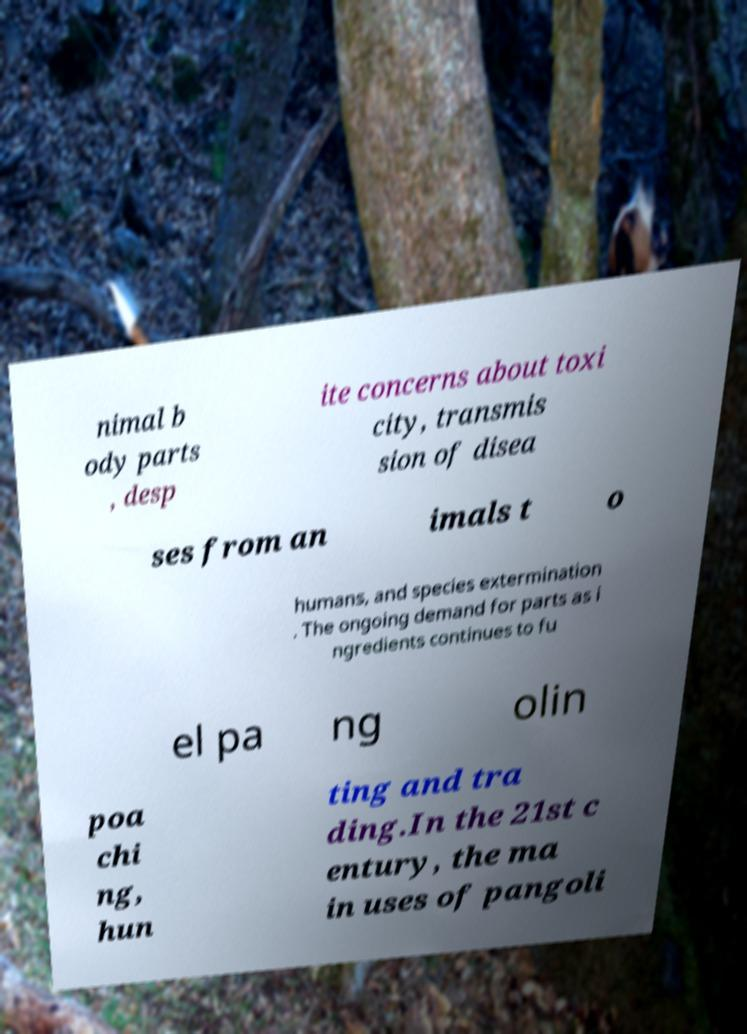What messages or text are displayed in this image? I need them in a readable, typed format. nimal b ody parts , desp ite concerns about toxi city, transmis sion of disea ses from an imals t o humans, and species extermination . The ongoing demand for parts as i ngredients continues to fu el pa ng olin poa chi ng, hun ting and tra ding.In the 21st c entury, the ma in uses of pangoli 